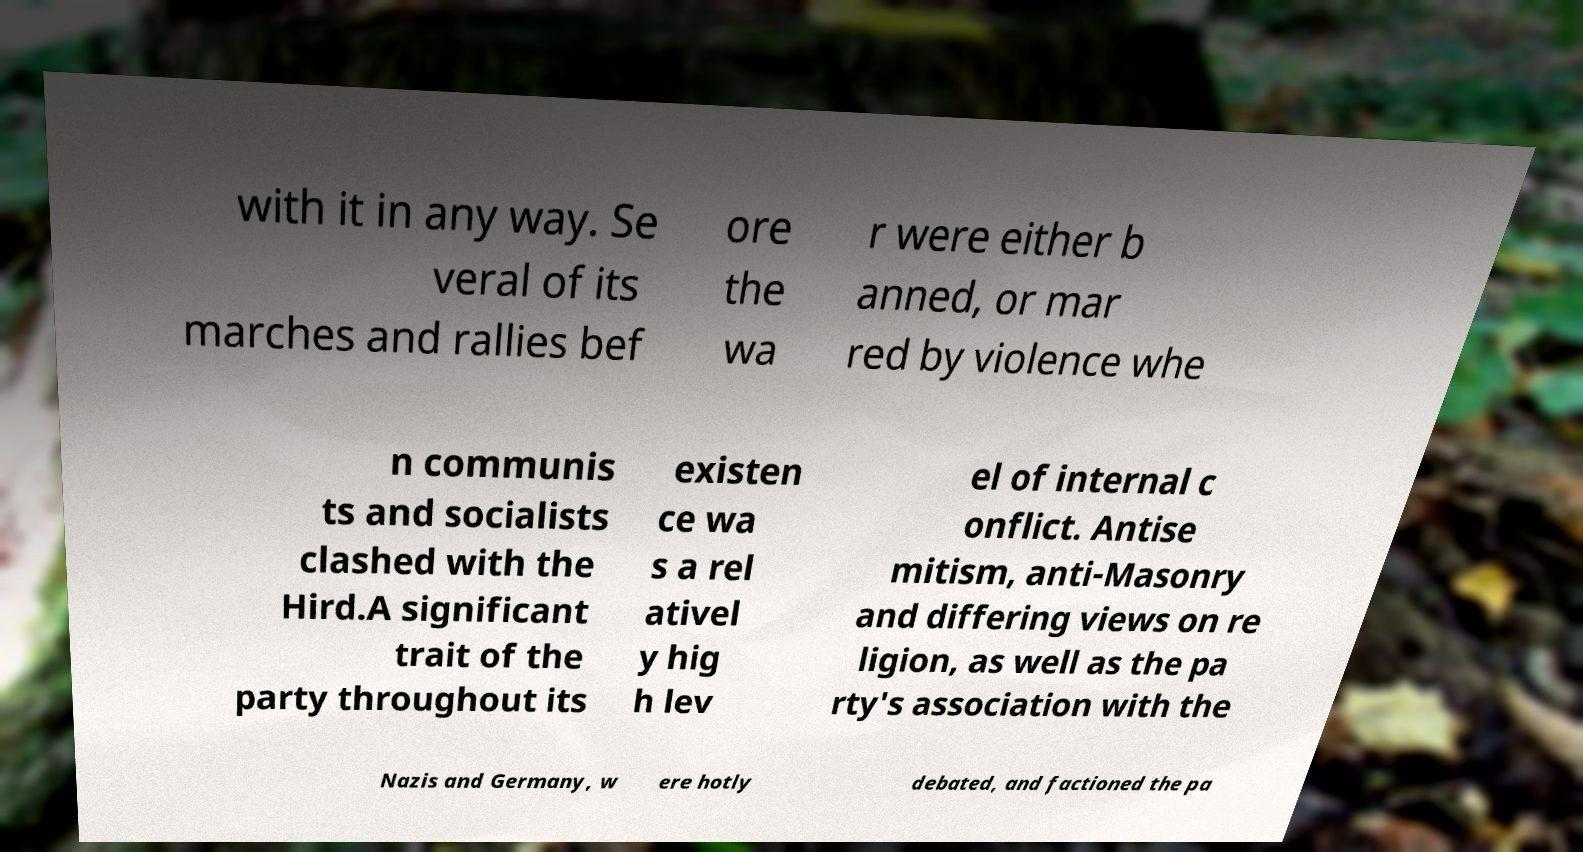Please read and relay the text visible in this image. What does it say? with it in any way. Se veral of its marches and rallies bef ore the wa r were either b anned, or mar red by violence whe n communis ts and socialists clashed with the Hird.A significant trait of the party throughout its existen ce wa s a rel ativel y hig h lev el of internal c onflict. Antise mitism, anti-Masonry and differing views on re ligion, as well as the pa rty's association with the Nazis and Germany, w ere hotly debated, and factioned the pa 